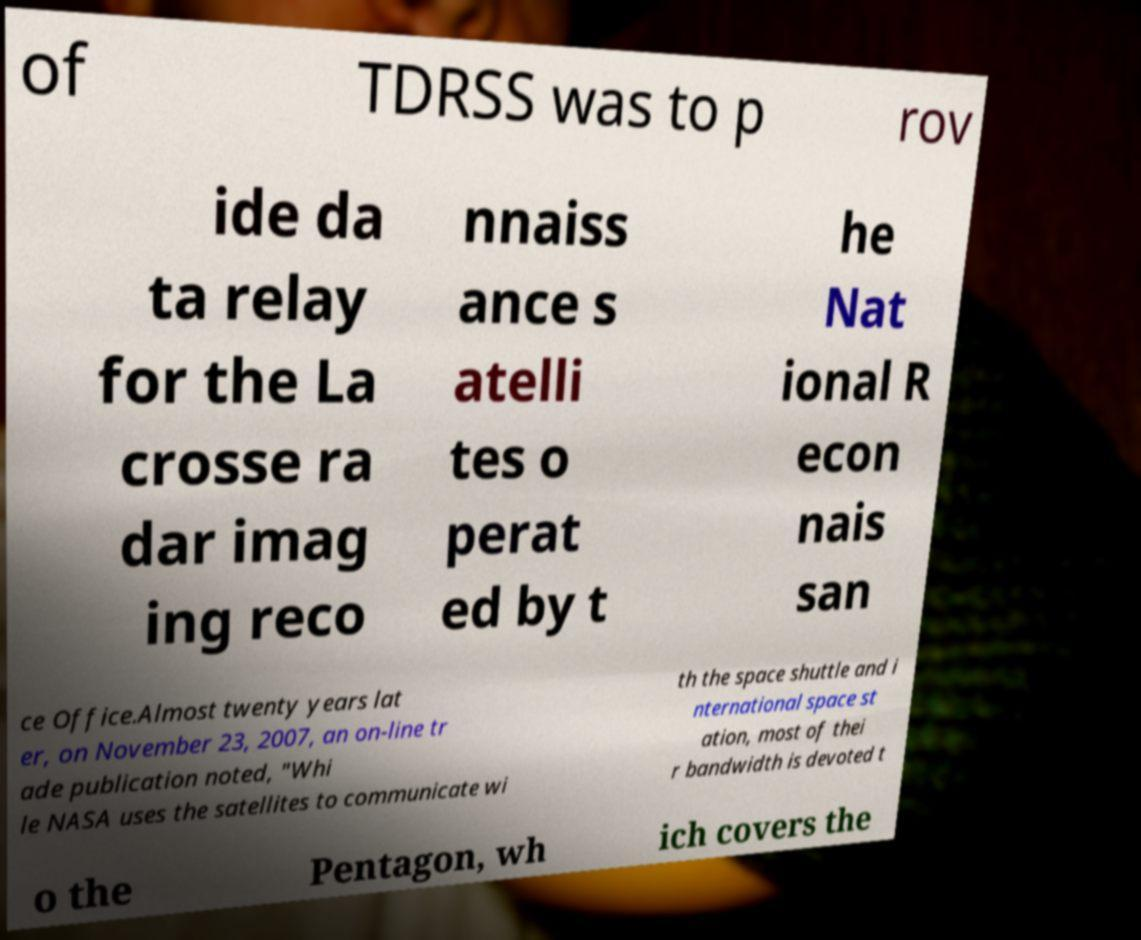Can you read and provide the text displayed in the image?This photo seems to have some interesting text. Can you extract and type it out for me? of TDRSS was to p rov ide da ta relay for the La crosse ra dar imag ing reco nnaiss ance s atelli tes o perat ed by t he Nat ional R econ nais san ce Office.Almost twenty years lat er, on November 23, 2007, an on-line tr ade publication noted, "Whi le NASA uses the satellites to communicate wi th the space shuttle and i nternational space st ation, most of thei r bandwidth is devoted t o the Pentagon, wh ich covers the 